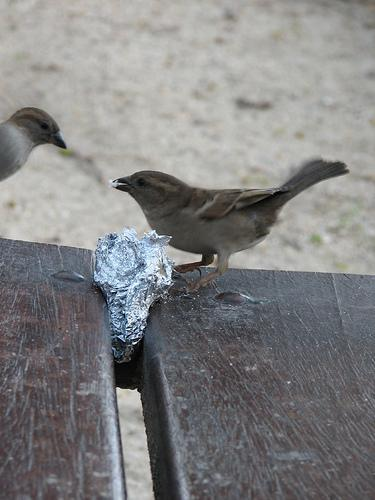What is tinfoil made of? Please explain your reasoning. tin. Foil is made out of tin. 